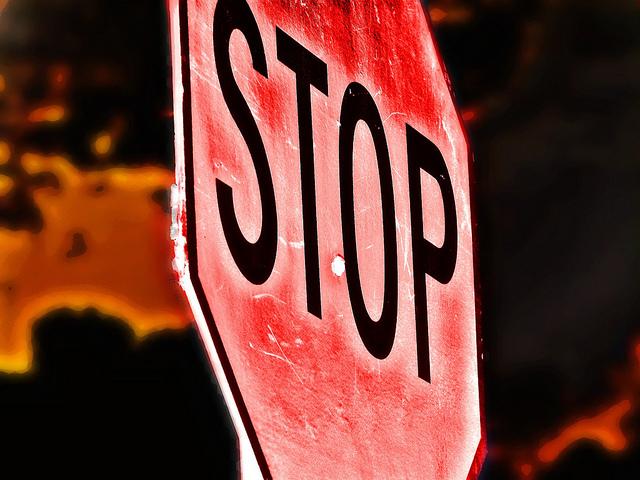Are these the right colors for a normal stop sign?
Keep it brief. No. What type of sign is posted?
Concise answer only. Stop. What is the shape of this sign?
Give a very brief answer. Octagon. 